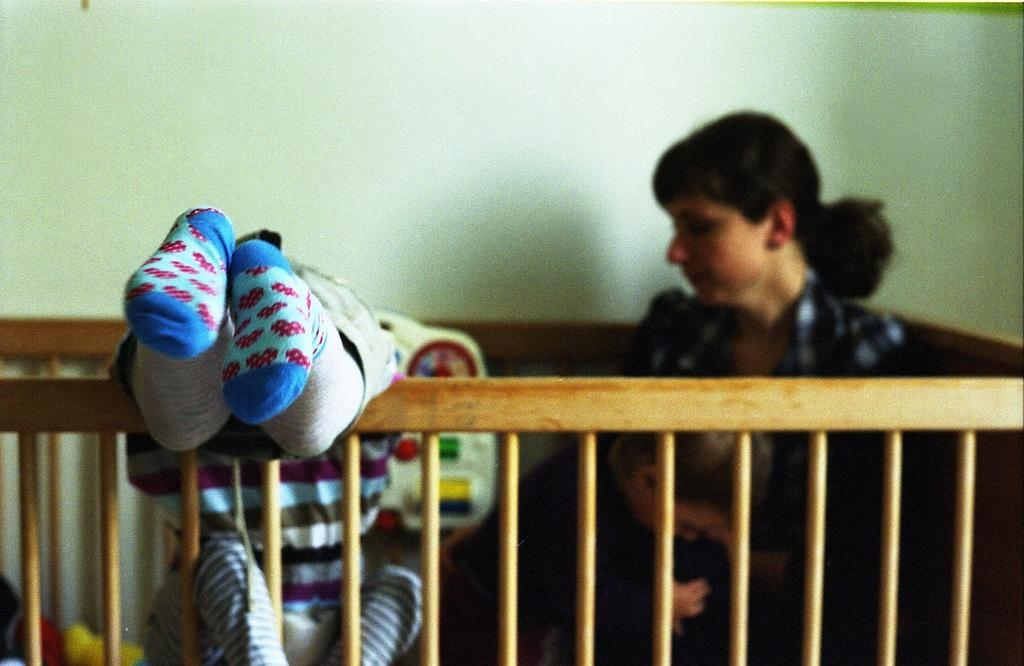Where was the image taken? The image was taken indoors. What can be seen on the left side of the image? There is a kid on the left side of the image. What is the position of the person in the image? There is a person sitting in the image. What type of objects are visible in the image? Wooden sticks are visible in the image. What is visible in the background of the image? There is a wall in the background of the image. What type of cord is being twisted by the kid in the image? There is no cord present in the image, and the kid is not twisting anything. 